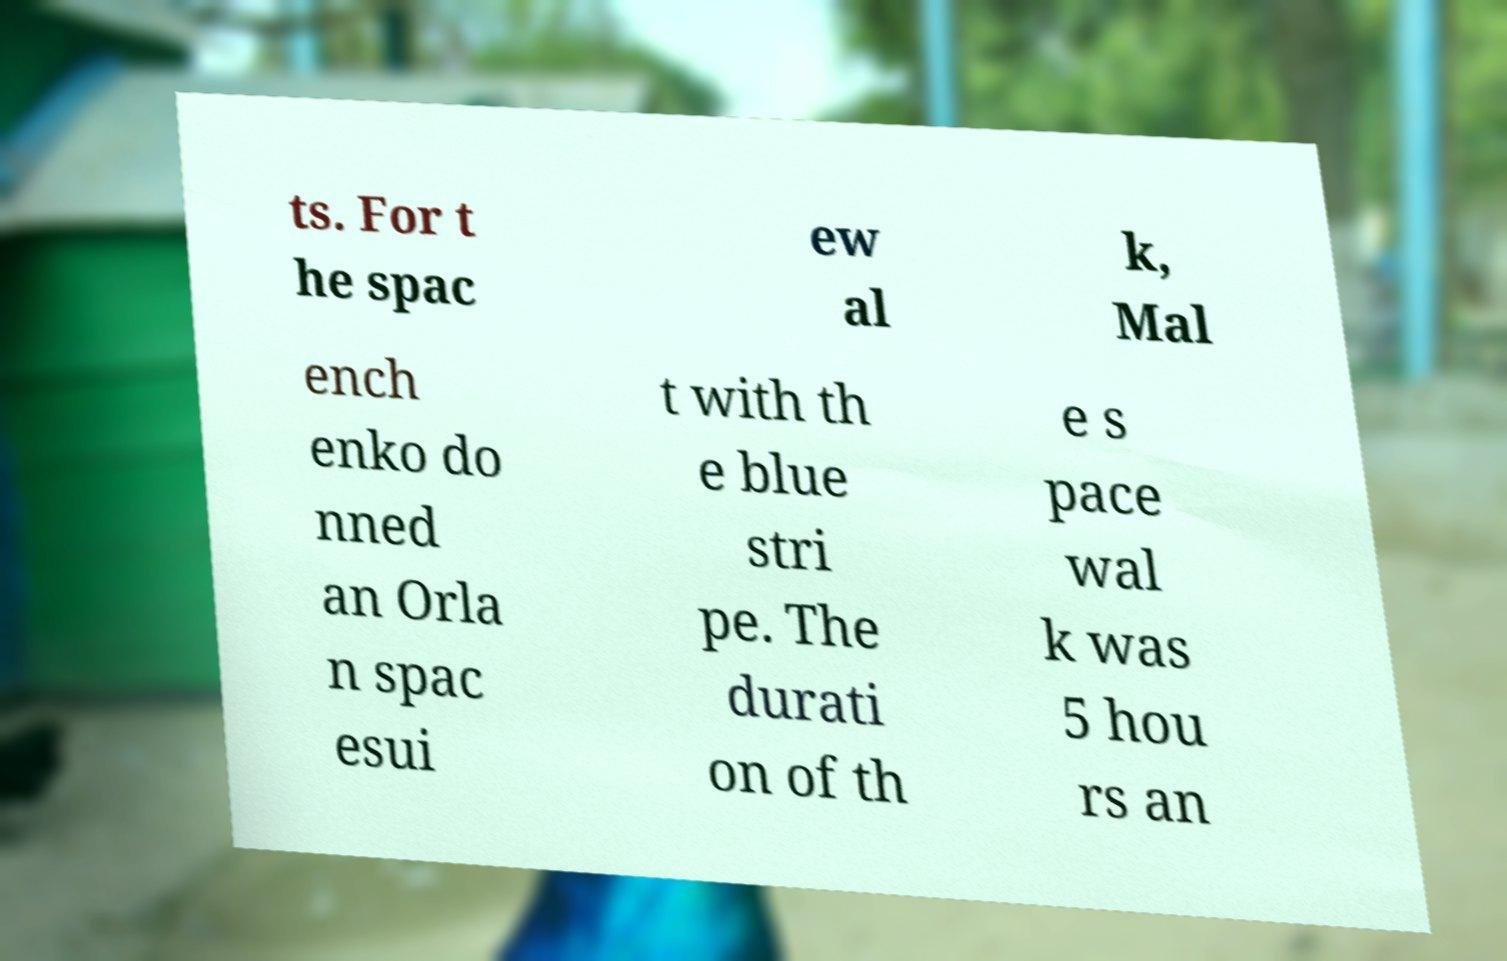There's text embedded in this image that I need extracted. Can you transcribe it verbatim? ts. For t he spac ew al k, Mal ench enko do nned an Orla n spac esui t with th e blue stri pe. The durati on of th e s pace wal k was 5 hou rs an 